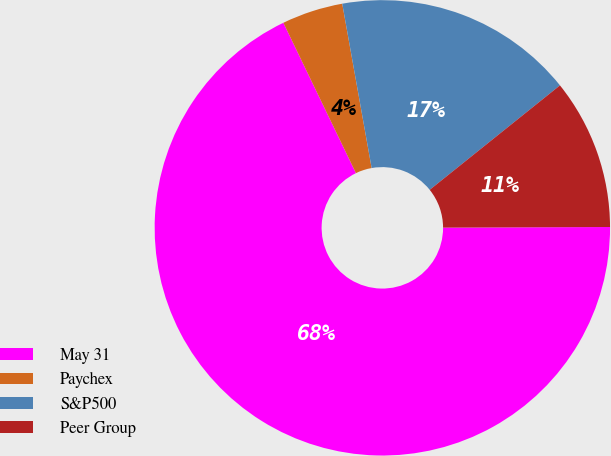Convert chart to OTSL. <chart><loc_0><loc_0><loc_500><loc_500><pie_chart><fcel>May 31<fcel>Paychex<fcel>S&P500<fcel>Peer Group<nl><fcel>67.9%<fcel>4.34%<fcel>17.06%<fcel>10.7%<nl></chart> 